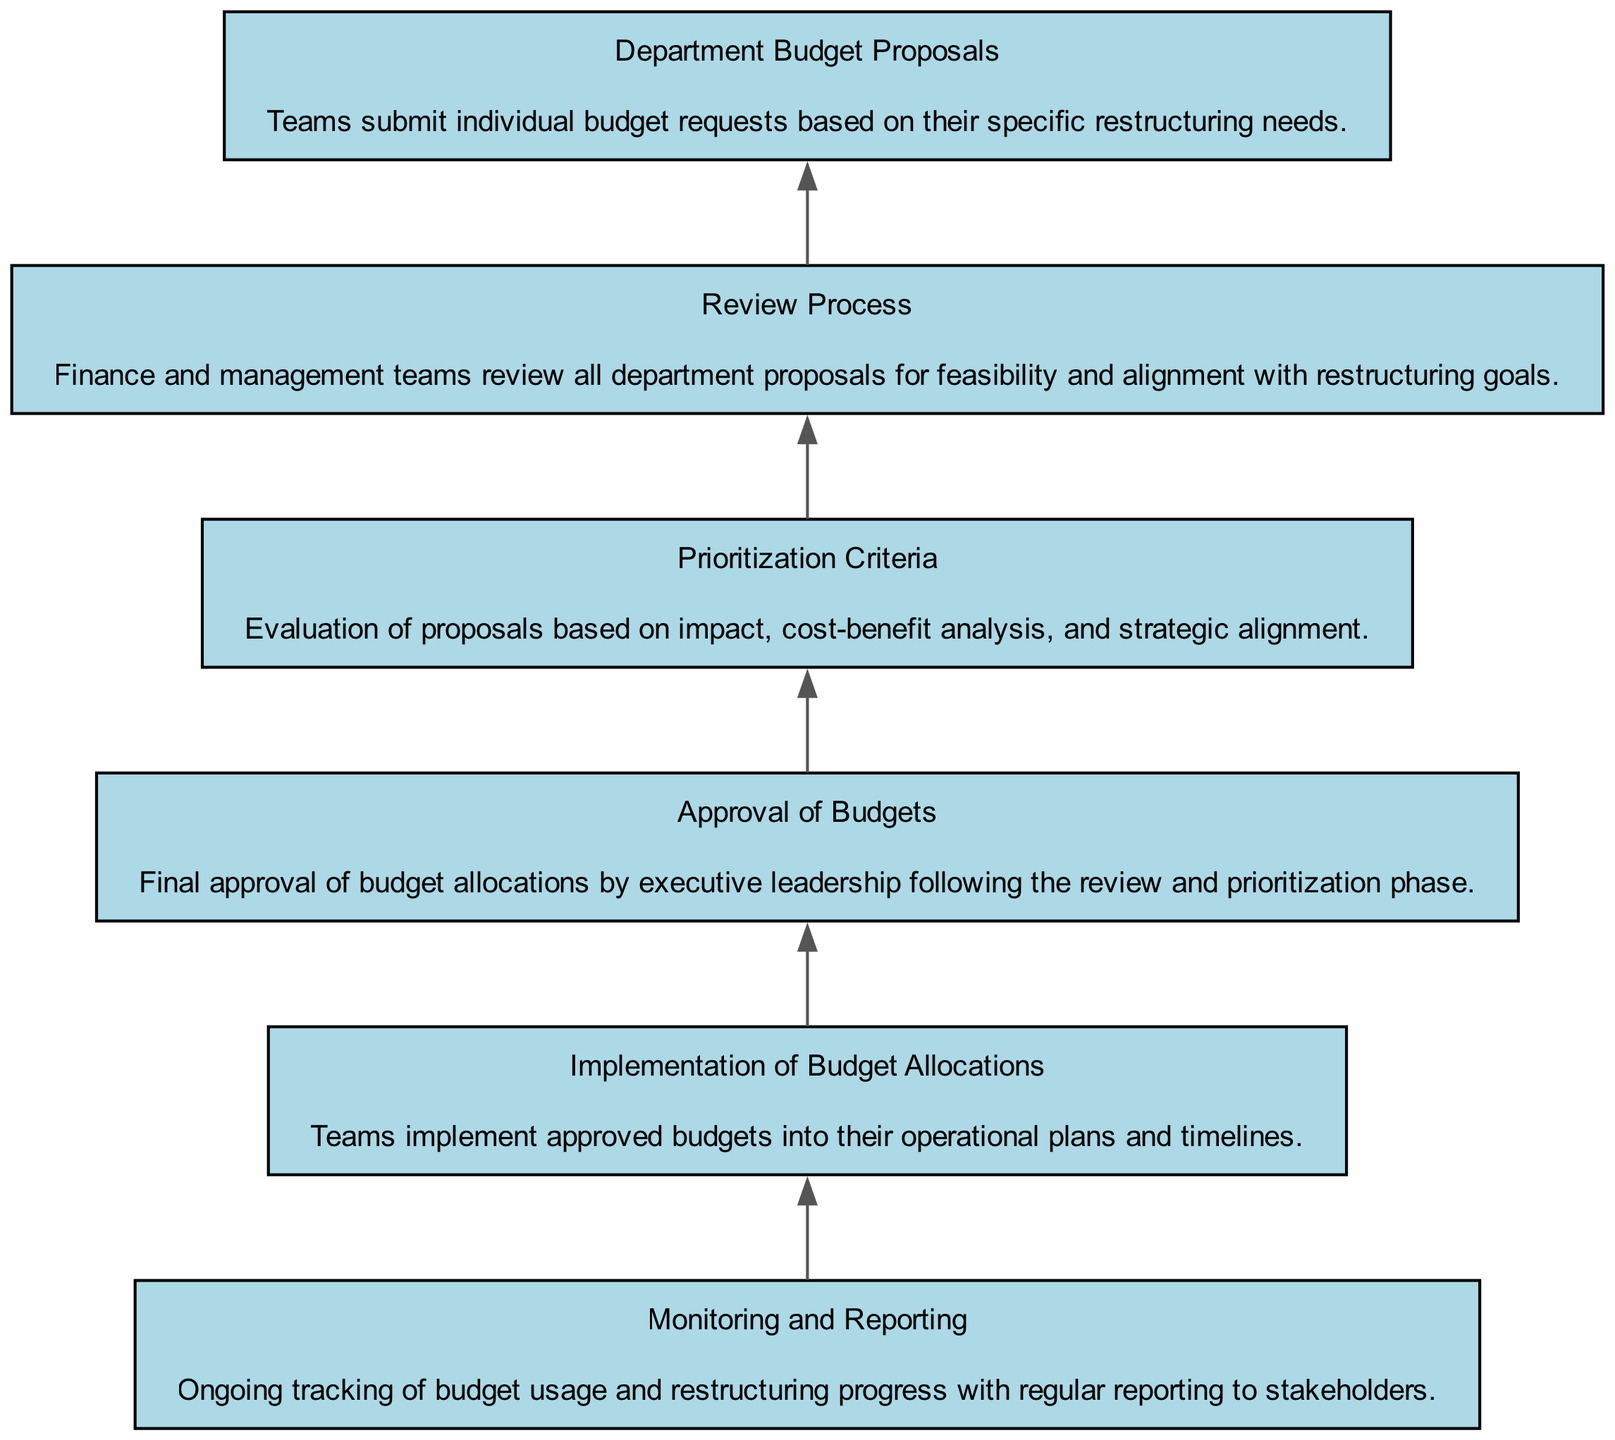What is the first step in the budget allocation process? The first step in the budget allocation process is "Department Budget Proposals", where teams submit individual budget requests based on their specific restructuring needs.
Answer: Department Budget Proposals How many nodes are present in the diagram? The diagram contains six elements (nodes) that depict different stages of the budget allocation process.
Answer: Six What follows after the Review Process? The "Prioritization Criteria" step follows after the "Review Process," where evaluation of proposals is based on impact, cost-benefit analysis, and strategic alignment.
Answer: Prioritization Criteria Which node is directly linked to the Implementation of Budget Allocations? The "Implementation of Budget Allocations" node is directly linked to the "Approval of Budgets" node, indicating that teams implement budgets only after they have been approved.
Answer: Approval of Budgets What is the last step in this budget allocation process? The last step in the budget allocation process is "Monitoring and Reporting," where ongoing tracking of budget usage and restructuring progress occurs.
Answer: Monitoring and Reporting How does the prioritization criteria impact the approval of budgets? The prioritization criteria influence the approval of budgets by assessing proposals on various metrics that includes impact, which in turn ensures that budgets allocated closely align with the restructuring goals before final approval is given.
Answer: Evaluation What is checked during the Review Process? During the "Review Process," finance and management teams review all department proposals for feasibility and how well they align with restructuring goals.
Answer: Feasibility and alignment Which node shows the ongoing tracking of budget usage? The node "Monitoring and Reporting" shows the ongoing tracking of budget usage and progress related to restructuring efforts.
Answer: Monitoring and Reporting What is the primary focus of the Department Budget Proposals node? The primary focus of the "Department Budget Proposals" node is for teams to submit individual budget requests tailored to their specific restructuring needs.
Answer: Specific restructuring needs 